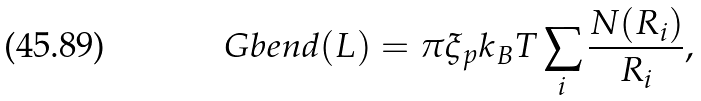<formula> <loc_0><loc_0><loc_500><loc_500>\ G b e n d ( L ) = \pi \xi _ { p } k _ { B } T \sum _ { i } \frac { N ( R _ { i } ) } { R _ { i } } ,</formula> 